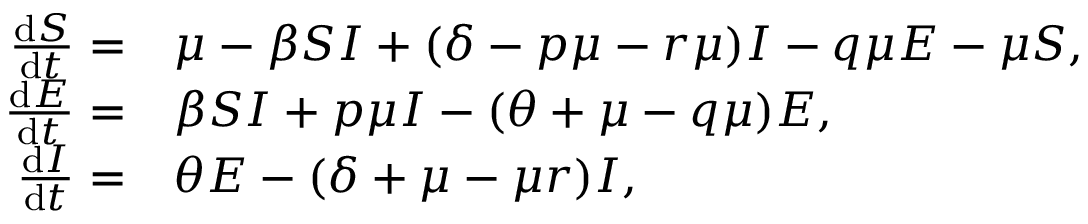Convert formula to latex. <formula><loc_0><loc_0><loc_500><loc_500>\begin{array} { r l } { \frac { d S } { d t } = } & { \mu - \beta S I + ( \delta - p \mu - r \mu ) I - q \mu E - \mu S , } \\ { \frac { d E } { d t } = } & { \beta S I + p \mu I - ( \theta + \mu - q \mu ) E , } \\ { \frac { d I } { d t } = } & { \theta E - ( \delta + \mu - \mu r ) I , } \end{array}</formula> 